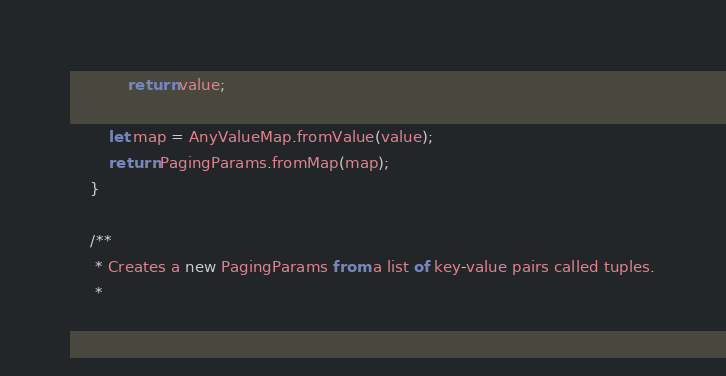Convert code to text. <code><loc_0><loc_0><loc_500><loc_500><_TypeScript_>			return value;

		let map = AnyValueMap.fromValue(value);
		return PagingParams.fromMap(map);
	}
	
	/**
     * Creates a new PagingParams from a list of key-value pairs called tuples.
     * </code> 